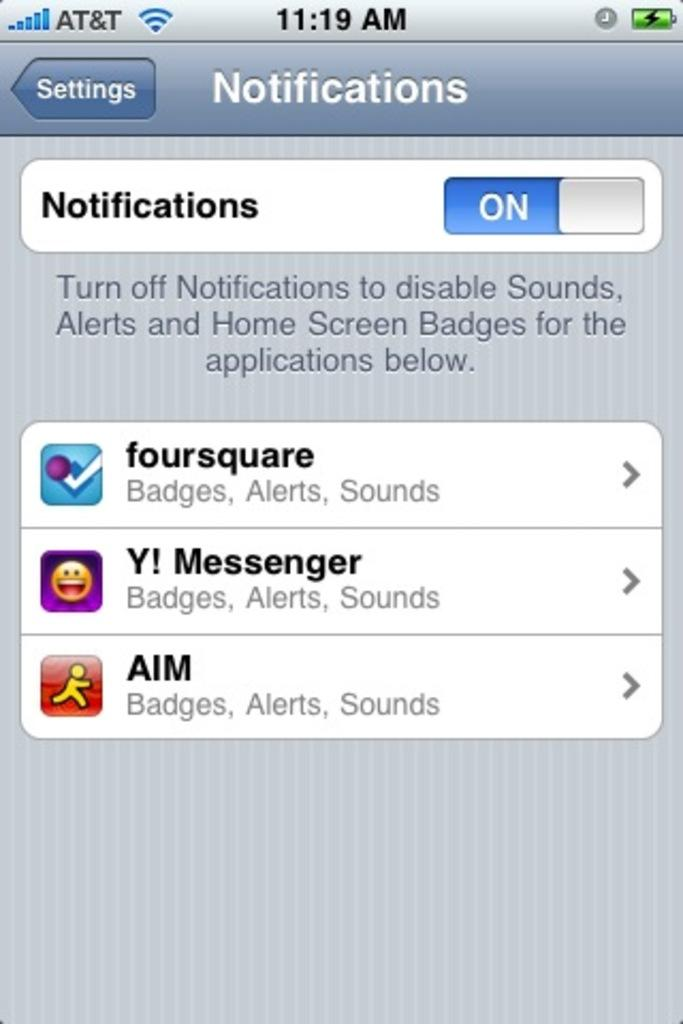<image>
Offer a succinct explanation of the picture presented. An AT&T cell phone showing Settings and Notifications at the top 